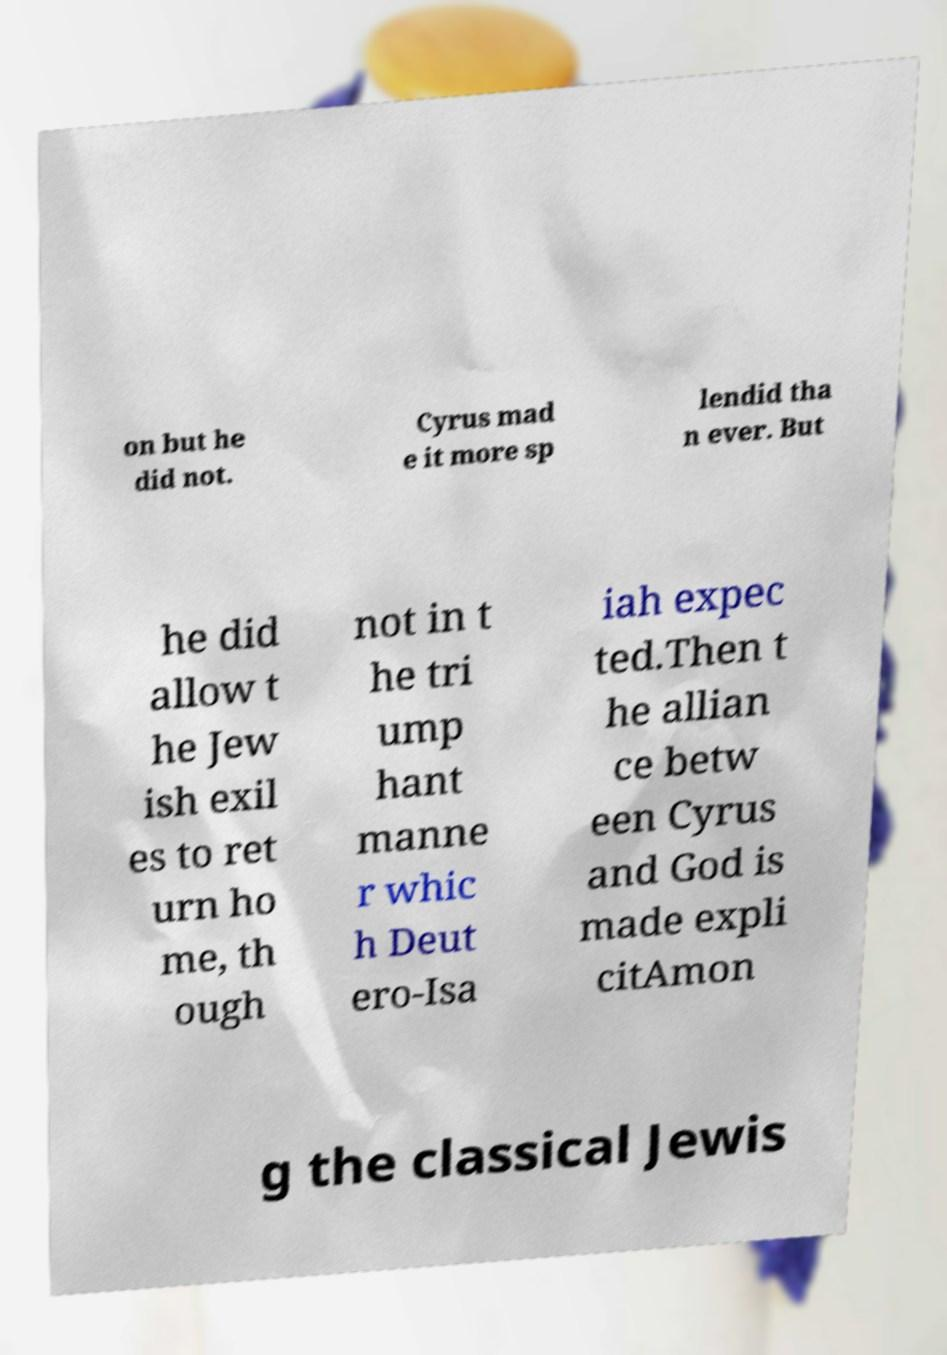There's text embedded in this image that I need extracted. Can you transcribe it verbatim? on but he did not. Cyrus mad e it more sp lendid tha n ever. But he did allow t he Jew ish exil es to ret urn ho me, th ough not in t he tri ump hant manne r whic h Deut ero-Isa iah expec ted.Then t he allian ce betw een Cyrus and God is made expli citAmon g the classical Jewis 